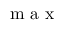Convert formula to latex. <formula><loc_0><loc_0><loc_500><loc_500>m a x</formula> 